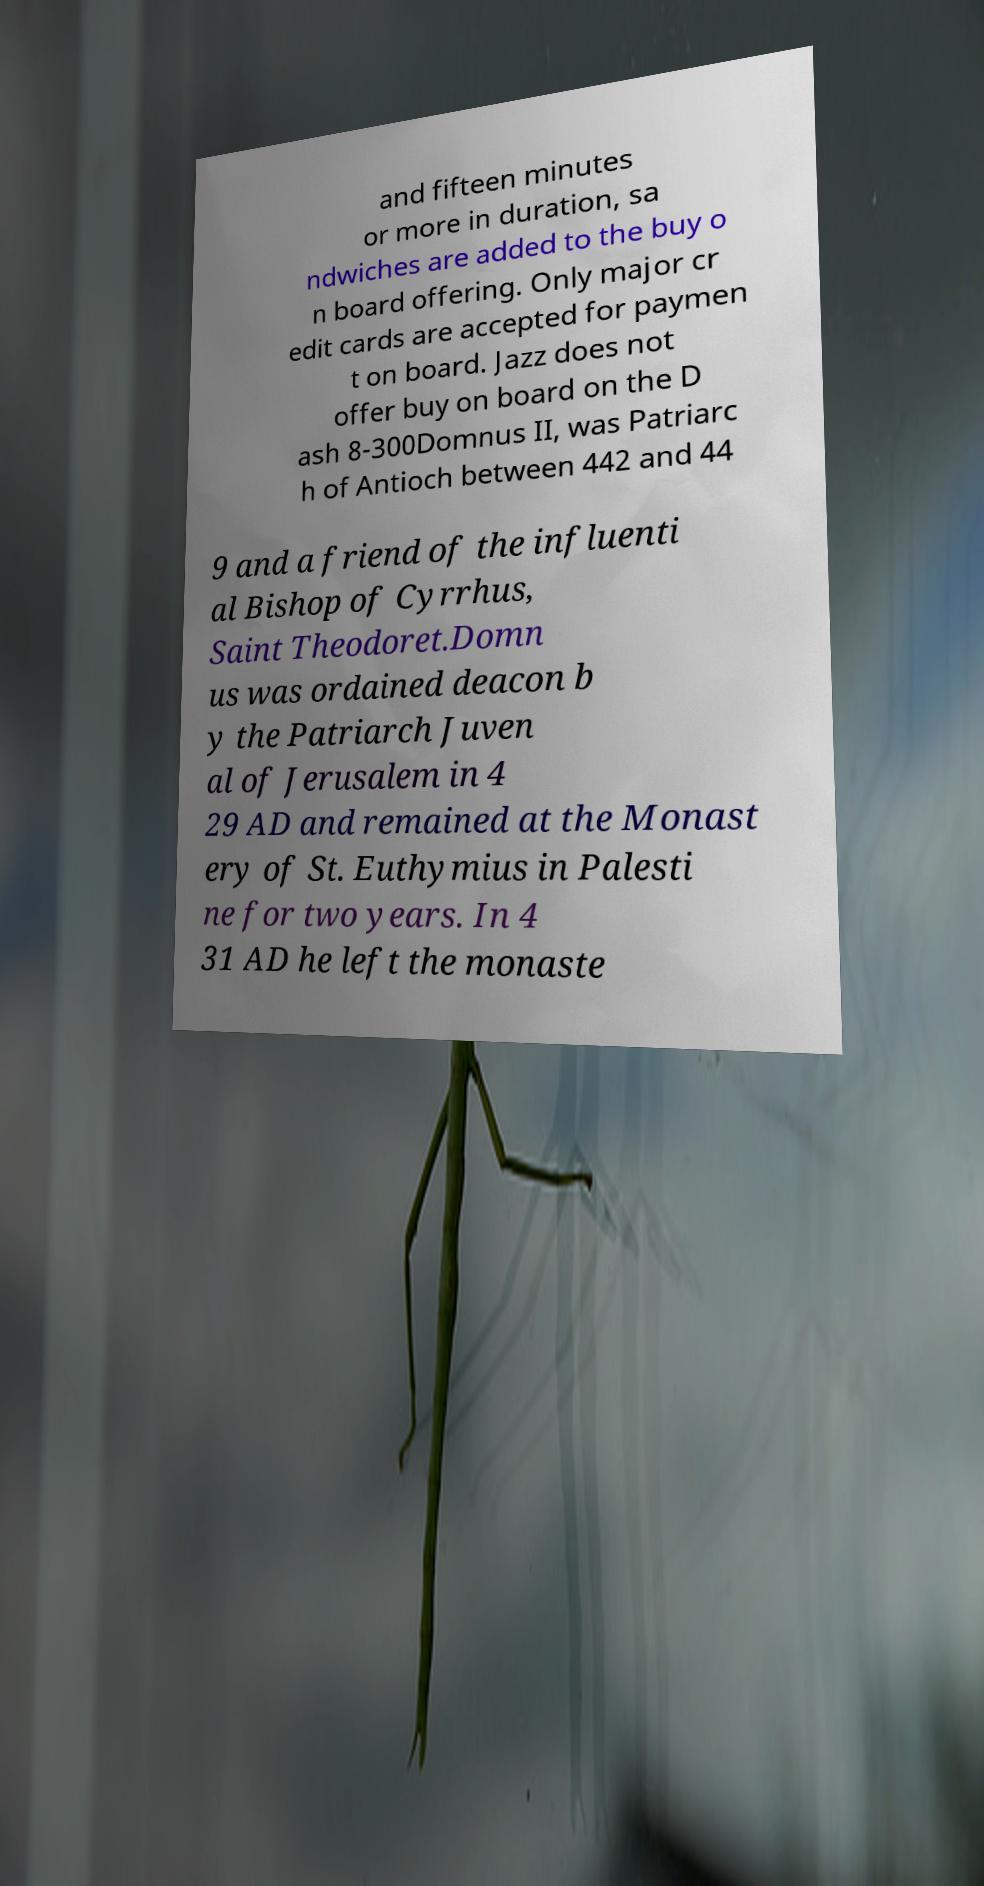Can you read and provide the text displayed in the image?This photo seems to have some interesting text. Can you extract and type it out for me? and fifteen minutes or more in duration, sa ndwiches are added to the buy o n board offering. Only major cr edit cards are accepted for paymen t on board. Jazz does not offer buy on board on the D ash 8-300Domnus II, was Patriarc h of Antioch between 442 and 44 9 and a friend of the influenti al Bishop of Cyrrhus, Saint Theodoret.Domn us was ordained deacon b y the Patriarch Juven al of Jerusalem in 4 29 AD and remained at the Monast ery of St. Euthymius in Palesti ne for two years. In 4 31 AD he left the monaste 